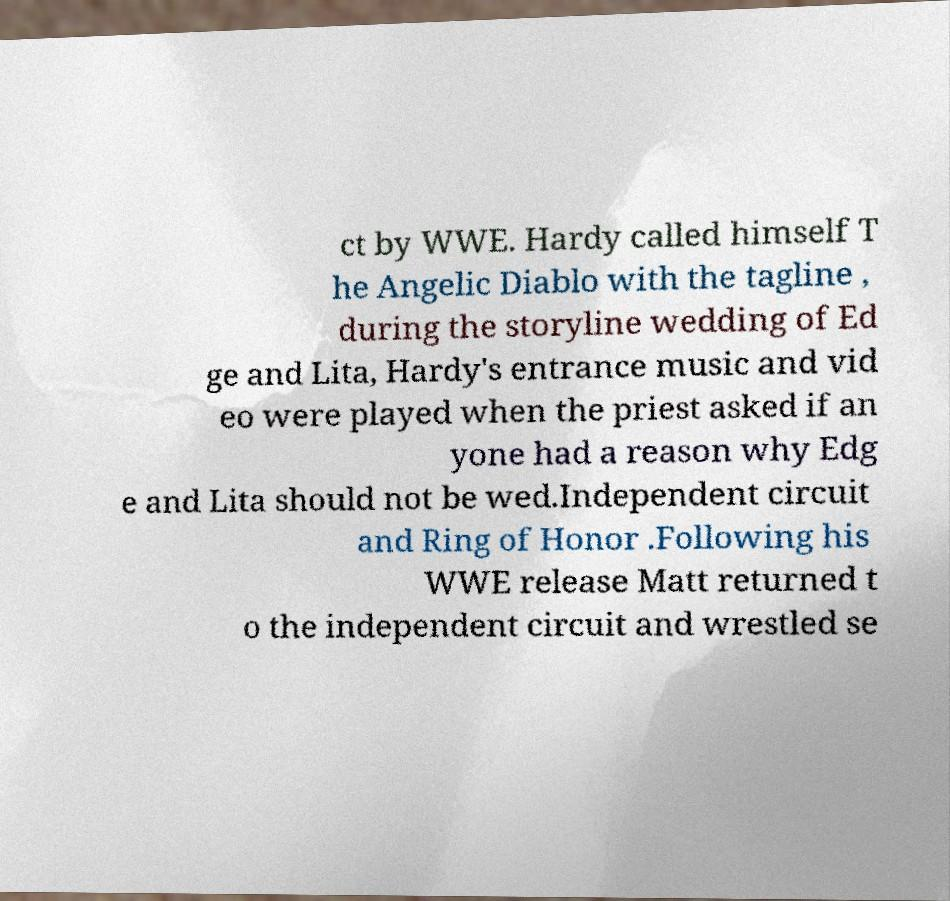Can you read and provide the text displayed in the image?This photo seems to have some interesting text. Can you extract and type it out for me? ct by WWE. Hardy called himself T he Angelic Diablo with the tagline , during the storyline wedding of Ed ge and Lita, Hardy's entrance music and vid eo were played when the priest asked if an yone had a reason why Edg e and Lita should not be wed.Independent circuit and Ring of Honor .Following his WWE release Matt returned t o the independent circuit and wrestled se 